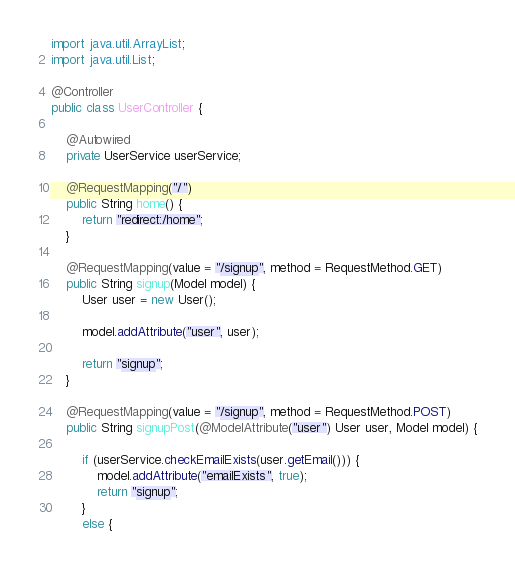Convert code to text. <code><loc_0><loc_0><loc_500><loc_500><_Java_>
import java.util.ArrayList;
import java.util.List;

@Controller
public class UserController {

    @Autowired
    private UserService userService;

    @RequestMapping("/")
    public String home() {
        return "redirect:/home";
    }

    @RequestMapping(value = "/signup", method = RequestMethod.GET)
    public String signup(Model model) {
        User user = new User();

        model.addAttribute("user", user);

        return "signup";
    }

    @RequestMapping(value = "/signup", method = RequestMethod.POST)
    public String signupPost(@ModelAttribute("user") User user, Model model) {

        if (userService.checkEmailExists(user.getEmail())) {
            model.addAttribute("emailExists", true);
            return "signup";
        }
        else {</code> 